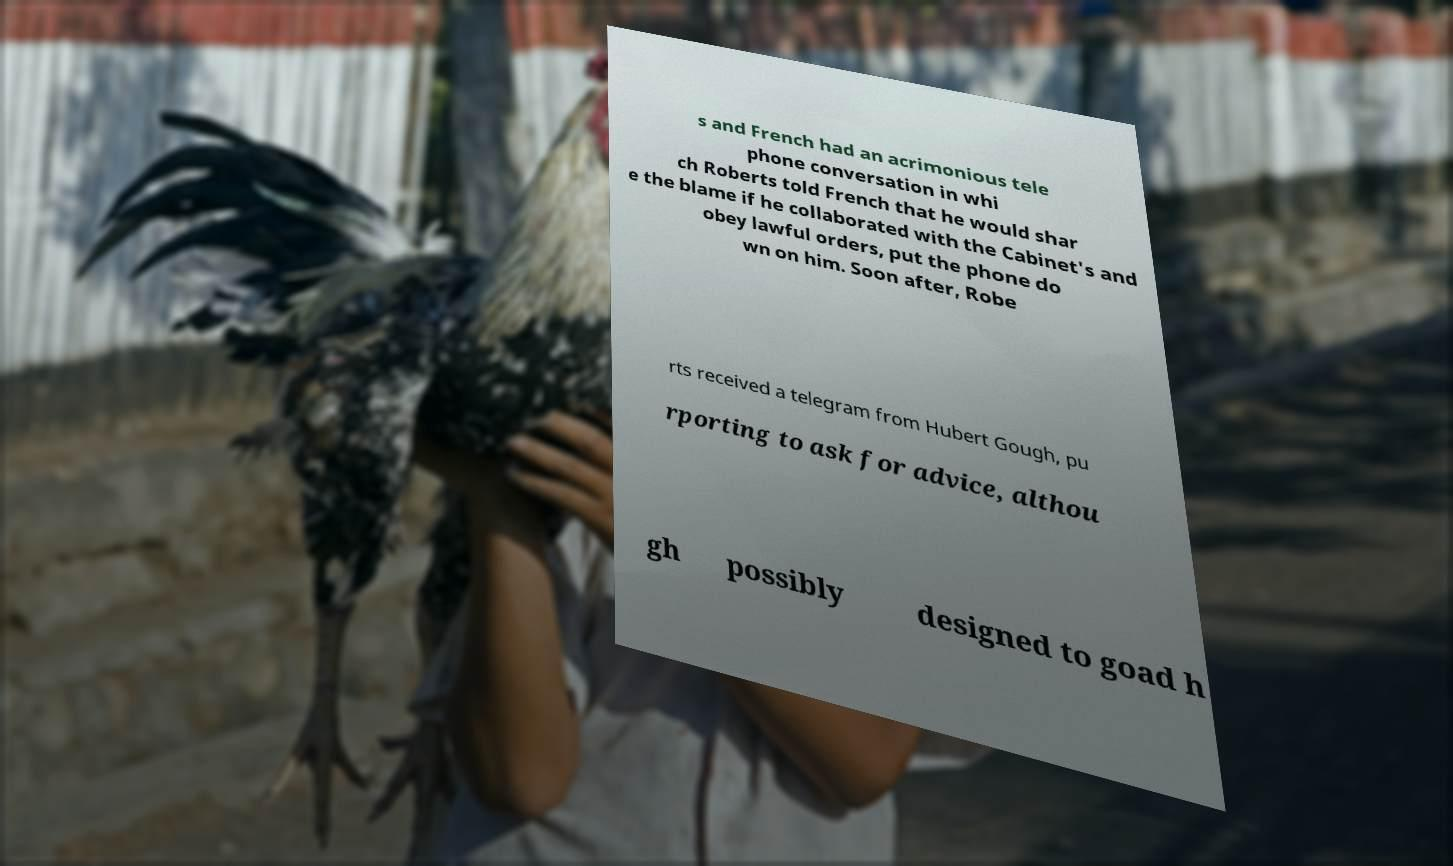I need the written content from this picture converted into text. Can you do that? s and French had an acrimonious tele phone conversation in whi ch Roberts told French that he would shar e the blame if he collaborated with the Cabinet's and obey lawful orders, put the phone do wn on him. Soon after, Robe rts received a telegram from Hubert Gough, pu rporting to ask for advice, althou gh possibly designed to goad h 